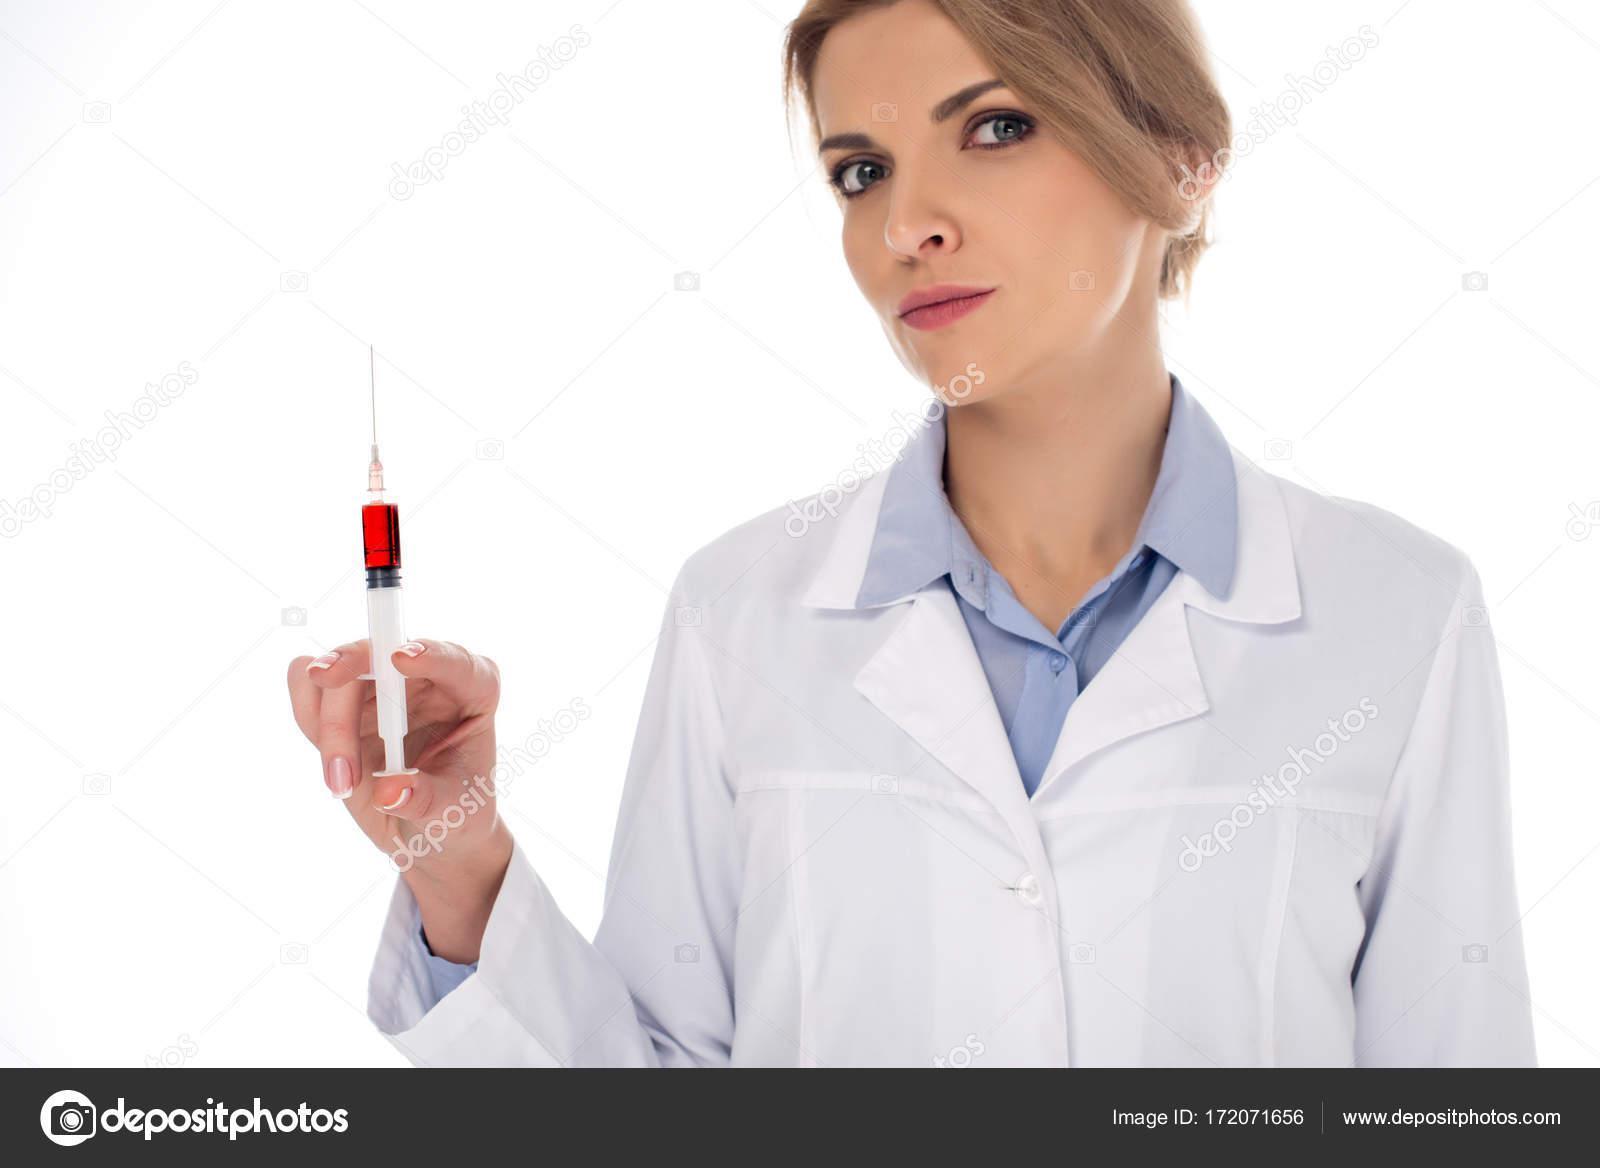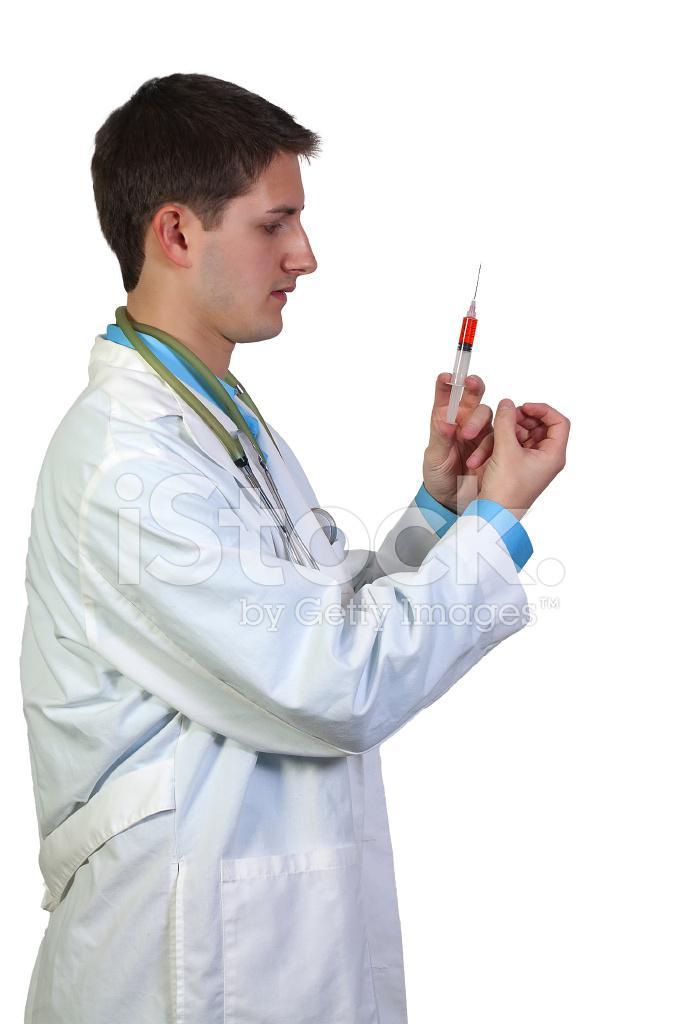The first image is the image on the left, the second image is the image on the right. Examine the images to the left and right. Is the description "A person is holding a hypdermic needle in a gloved hand in one image." accurate? Answer yes or no. No. The first image is the image on the left, the second image is the image on the right. Considering the images on both sides, is "Two women are holding syringes." valid? Answer yes or no. No. 